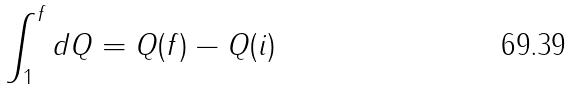<formula> <loc_0><loc_0><loc_500><loc_500>\int _ { 1 } ^ { f } d Q = Q ( f ) - Q ( i )</formula> 